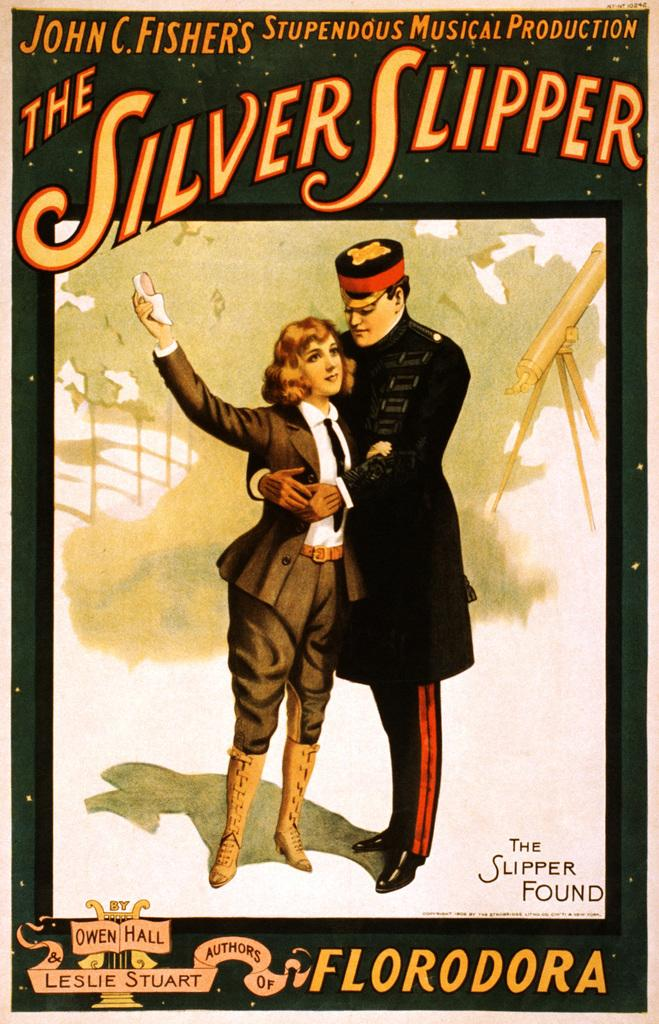Provide a one-sentence caption for the provided image. John C Fisher's The Silver Slipper movie poster. 